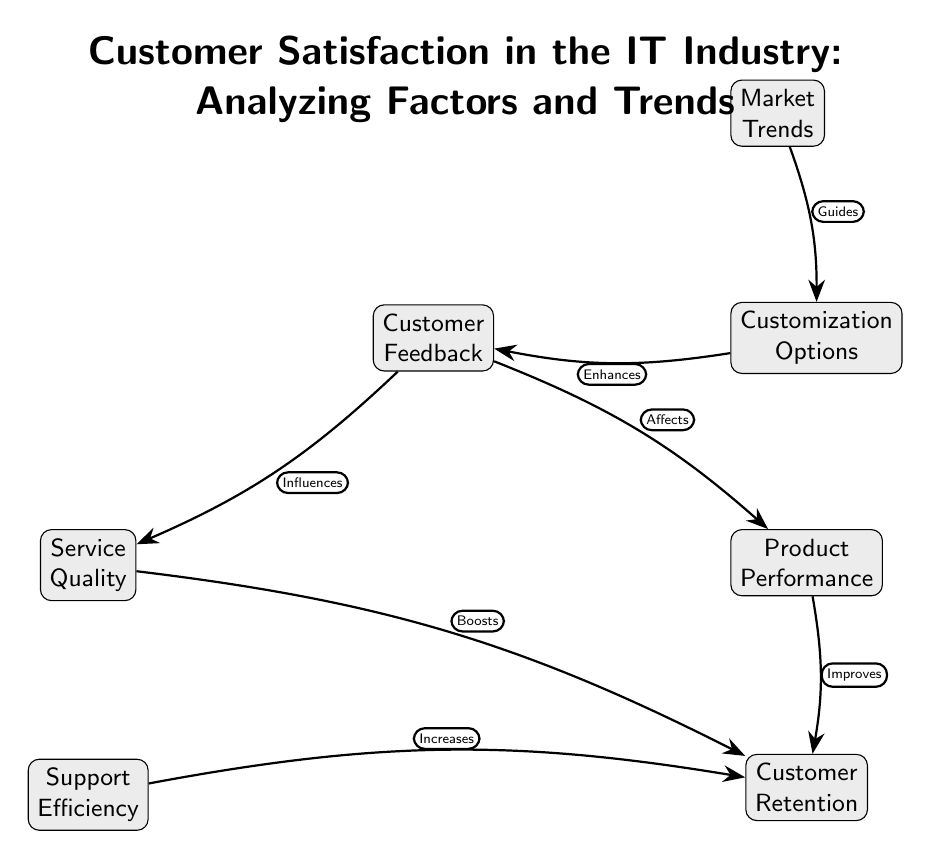What is the main title of the diagram? The title of the diagram is explicitly stated at the top, "Customer Satisfaction in the IT Industry: Analyzing Factors and Trends."
Answer: Customer Satisfaction in the IT Industry: Analyzing Factors and Trends How many nodes are present in the diagram? The diagram includes a total of seven nodes, which can be counted visually in the layout.
Answer: Seven What relationship is described between Customer Feedback and Service Quality? The diagram indicates that Customer Feedback "Influences" Service Quality, which is one of the directed edges in the diagram.
Answer: Influences Which node directly leads to Customer Retention? Customer Retention is directly influenced by three nodes: Service Quality, Product Performance, and Support Efficiency, as indicated by the edges leading to it.
Answer: Service Quality, Product Performance, Support Efficiency What action is associated with market trends in the diagram? The diagram mentions that Market Trends "Guides" Customization Options, outlining the relationship between these two nodes.
Answer: Guides What effect does product performance have on customer retention? According to the diagram, Product Performance "Improves" Customer Retention, showing a directional influence between these nodes.
Answer: Improves Which node enhances customer feedback according to the diagram? The diagram states that Customization Options "Enhances" Customer Feedback, indicating a positive relationship directed back to Customer Feedback.
Answer: Enhances What are two factors that influence customer retention? The diagram clearly shows that Service Quality and Product Performance are two nodes that boost Customer Retention, as demonstrated by the directed edges.
Answer: Service Quality, Product Performance 